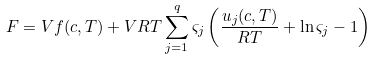Convert formula to latex. <formula><loc_0><loc_0><loc_500><loc_500>F = V f ( c , T ) + V R T \sum _ { j = 1 } ^ { q } \varsigma _ { j } \left ( \frac { u _ { j } ( c , T ) } { R T } + \ln \varsigma _ { j } - 1 \right )</formula> 